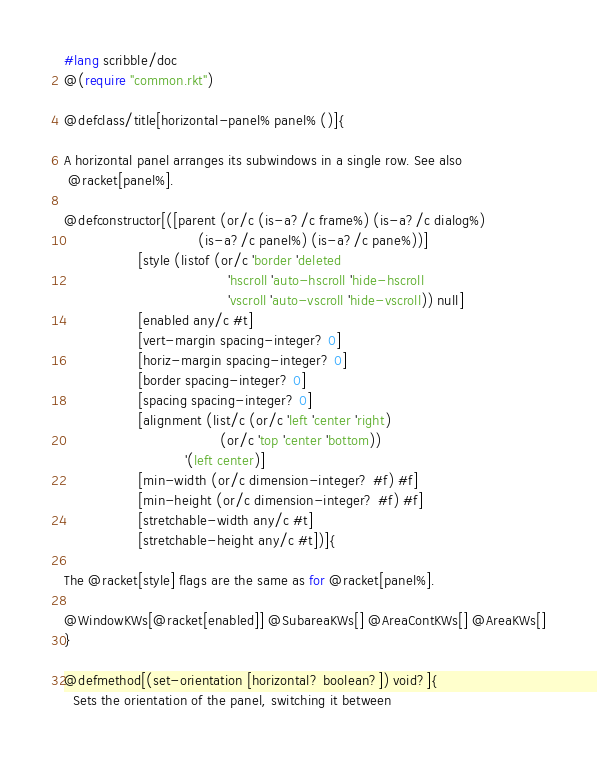<code> <loc_0><loc_0><loc_500><loc_500><_Racket_>#lang scribble/doc
@(require "common.rkt")

@defclass/title[horizontal-panel% panel% ()]{

A horizontal panel arranges its subwindows in a single row. See also
 @racket[panel%].

@defconstructor[([parent (or/c (is-a?/c frame%) (is-a?/c dialog%) 
                               (is-a?/c panel%) (is-a?/c pane%))]
                 [style (listof (or/c 'border 'deleted
                                      'hscroll 'auto-hscroll 'hide-hscroll
                                      'vscroll 'auto-vscroll 'hide-vscroll)) null]
                 [enabled any/c #t]
                 [vert-margin spacing-integer? 0]
                 [horiz-margin spacing-integer? 0]
                 [border spacing-integer? 0]
                 [spacing spacing-integer? 0]
                 [alignment (list/c (or/c 'left 'center 'right)
                                    (or/c 'top 'center 'bottom))
                            '(left center)]
                 [min-width (or/c dimension-integer? #f) #f]
                 [min-height (or/c dimension-integer? #f) #f]
                 [stretchable-width any/c #t]
                 [stretchable-height any/c #t])]{

The @racket[style] flags are the same as for @racket[panel%].

@WindowKWs[@racket[enabled]] @SubareaKWs[] @AreaContKWs[] @AreaKWs[]
}

@defmethod[(set-orientation [horizontal? boolean?]) void?]{
  Sets the orientation of the panel, switching it between</code> 